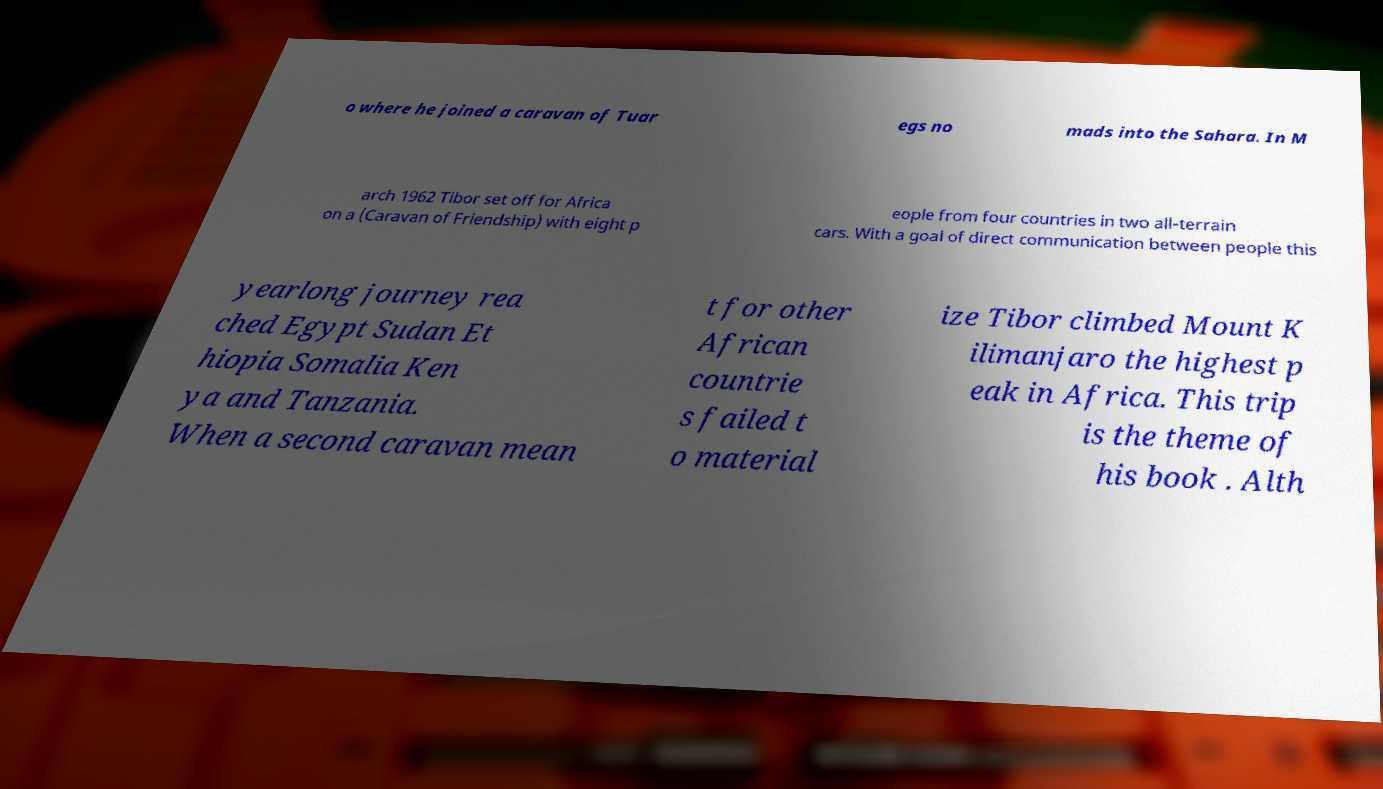Can you accurately transcribe the text from the provided image for me? o where he joined a caravan of Tuar egs no mads into the Sahara. In M arch 1962 Tibor set off for Africa on a (Caravan of Friendship) with eight p eople from four countries in two all-terrain cars. With a goal of direct communication between people this yearlong journey rea ched Egypt Sudan Et hiopia Somalia Ken ya and Tanzania. When a second caravan mean t for other African countrie s failed t o material ize Tibor climbed Mount K ilimanjaro the highest p eak in Africa. This trip is the theme of his book . Alth 